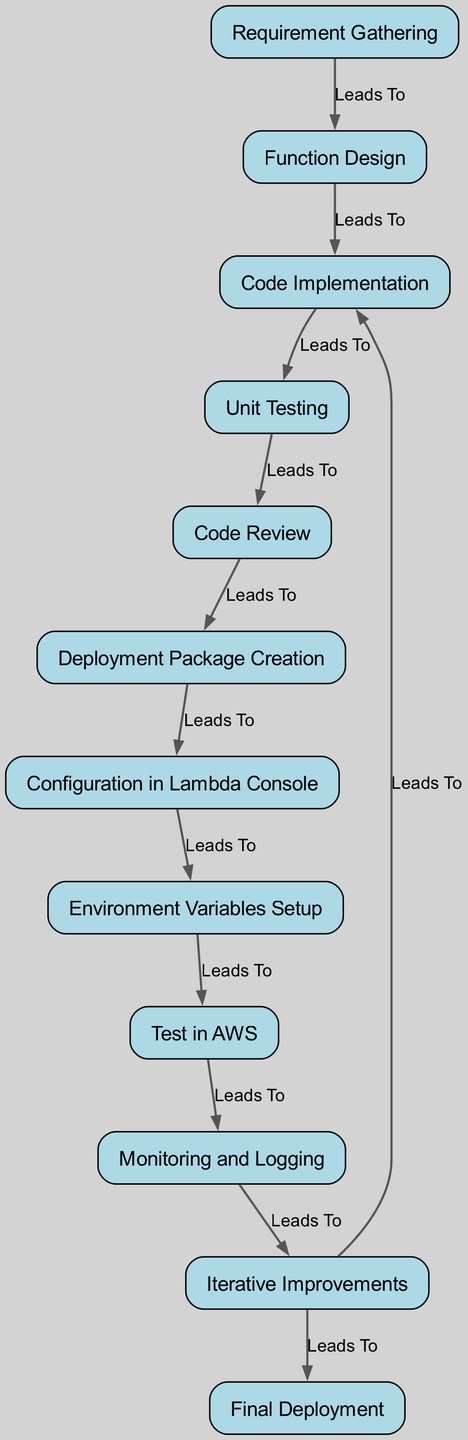What is the starting point of the AWS Lambda function lifecycle? The diagram shows "Requirement Gathering" as the initial node that leads to the first step in the lifecycle. It’s the first element mentioned with a direct relationship to the next step.
Answer: Requirement Gathering How many total steps are there in the lifecycle? By counting the nodes in the diagram, we see there are 12 elements, including steps from requirement gathering to final deployment.
Answer: Twelve What follows Code Implementation in the lifecycle? After "Code Implementation," the next step shown in the diagram is "Unit Testing," indicating the sequence of operations after the coding phase.
Answer: Unit Testing Which phase comes after Configuration in Lambda Console? The diagram shows "Environment Variables Setup" directly following "Configuration in Lambda Console," illustrating the order of tasks in this stage.
Answer: Environment Variables Setup What do "Iterative Improvements" lead to? "Iterative Improvements" lead back to "Code Implementation" as well as "Final Deployment," indicating a cycle of refinement before final deployment.
Answer: Code Implementation, Final Deployment Name one activity before Deployment Package Creation. The activity immediately preceding "Deployment Package Creation" according to the diagram is "Code Review," which ensures code quality before packaging.
Answer: Code Review How many nodes lead to "Final Deployment"? The diagram reveals that "Final Deployment" is reached from "Iterative Improvements" and has no other incoming relationships, so there is only one node leading to it.
Answer: One What is the final stage of the AWS Lambda function lifecycle? The end node in the diagram clearly indicates "Final Deployment" as the last step in the entire lifecycle process for an AWS Lambda function.
Answer: Final Deployment What is the relationship type between Code Review and Deployment Package Creation? This relationship is categorized as "leads_to," indicating that Code Review is a prerequisite for creating the deployment package.
Answer: Leads to 